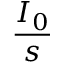<formula> <loc_0><loc_0><loc_500><loc_500>\frac { I _ { 0 } } { s }</formula> 